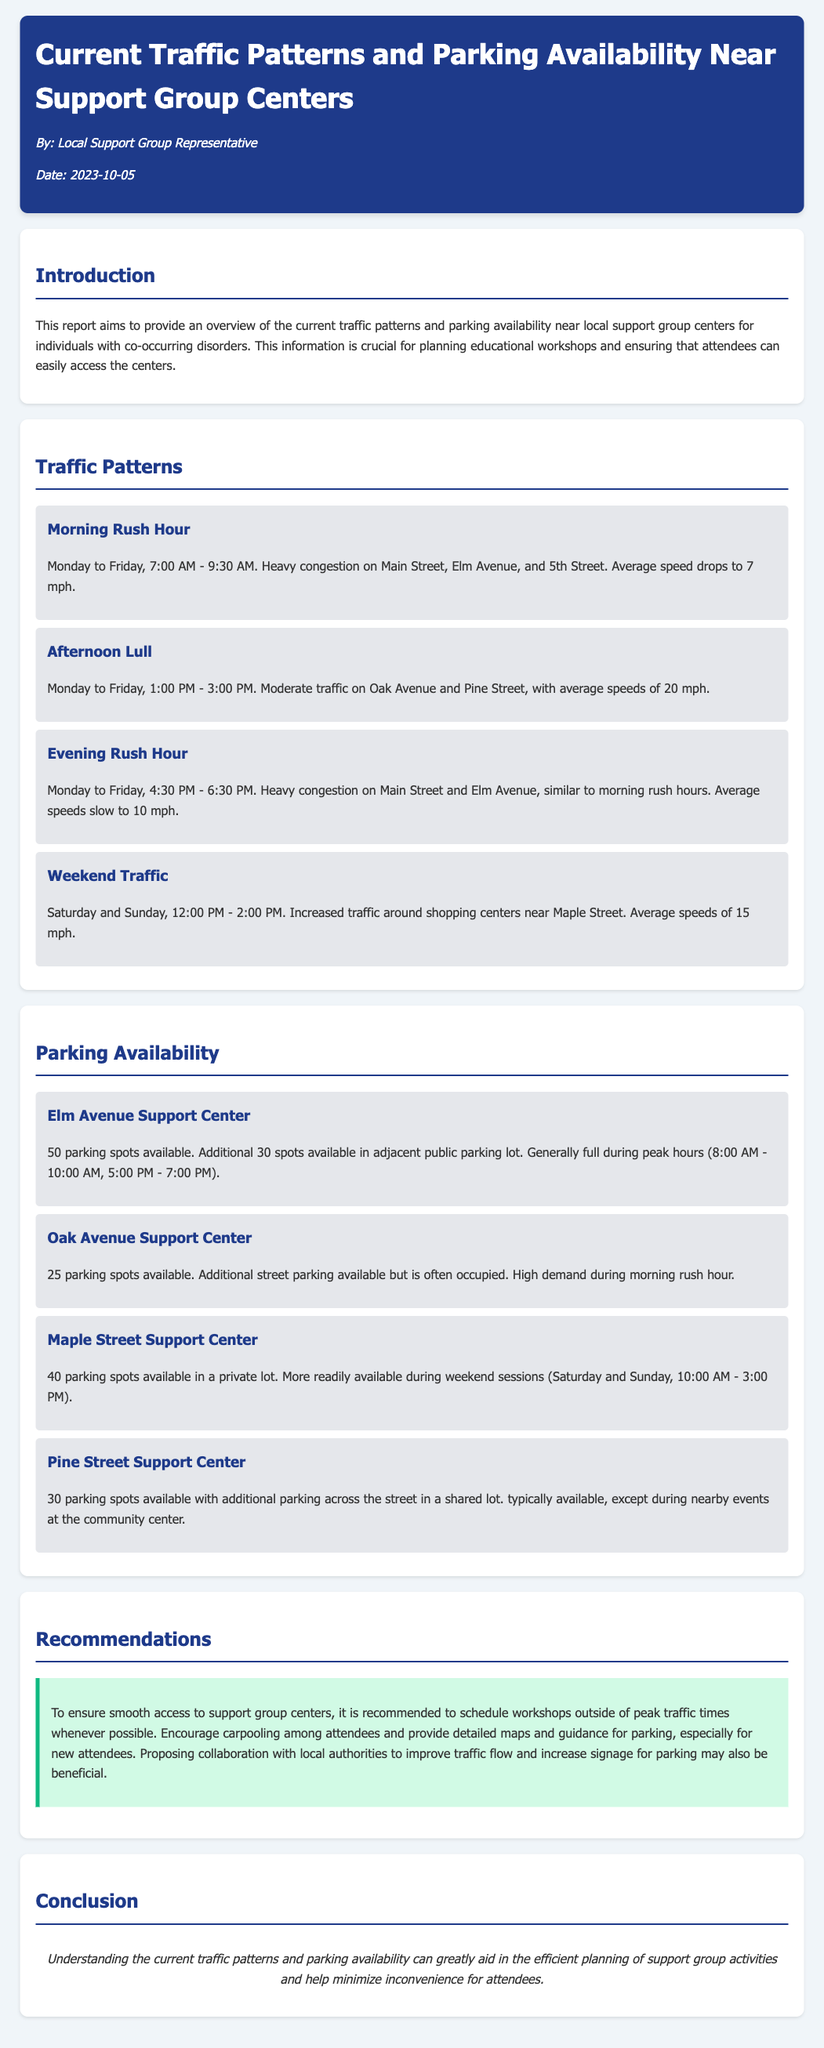What is the peak time for morning traffic? The document specifies that the peak time for morning traffic is from 7:00 AM to 9:30 AM.
Answer: 7:00 AM - 9:30 AM How many parking spots are available at the Elm Avenue Support Center? The Elm Avenue Support Center has 50 parking spots available.
Answer: 50 What is the average speed during the evening rush hour? The average speed during the evening rush hour drops to 10 mph.
Answer: 10 mph When is traffic increased around shopping centers? The document states that increased traffic occurs on weekends, specifically from 12:00 PM to 2:00 PM.
Answer: Saturday and Sunday, 12:00 PM - 2:00 PM What recommendation is made regarding parking guidance? The report suggests providing detailed maps and guidance for parking, especially for new attendees.
Answer: Detailed maps and guidance What is the parking availability during weekend sessions at the Maple Street Support Center? The Maple Street Support Center has more parking readily available during weekend sessions from 10:00 AM to 3:00 PM.
Answer: 10:00 AM - 3:00 PM What is the typical parking situation at Pine Street Support Center during events? The parking at Pine Street Support Center is typically available, except during nearby events at the community center.
Answer: Except during events What is the additional parking situation at the Oak Avenue Support Center? The Oak Avenue Support Center has additional street parking available, but it is often occupied.
Answer: Often occupied During which hours is the Elm Avenue Support Center generally full? The Elm Avenue Support Center is generally full during peak hours from 8:00 AM to 10:00 AM and 5:00 PM to 7:00 PM.
Answer: 8:00 AM - 10:00 AM, 5:00 PM - 7:00 PM 